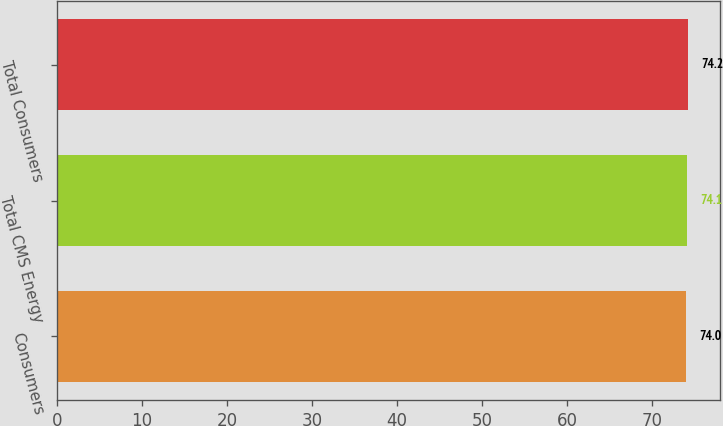Convert chart. <chart><loc_0><loc_0><loc_500><loc_500><bar_chart><fcel>Consumers<fcel>Total CMS Energy<fcel>Total Consumers<nl><fcel>74<fcel>74.1<fcel>74.2<nl></chart> 